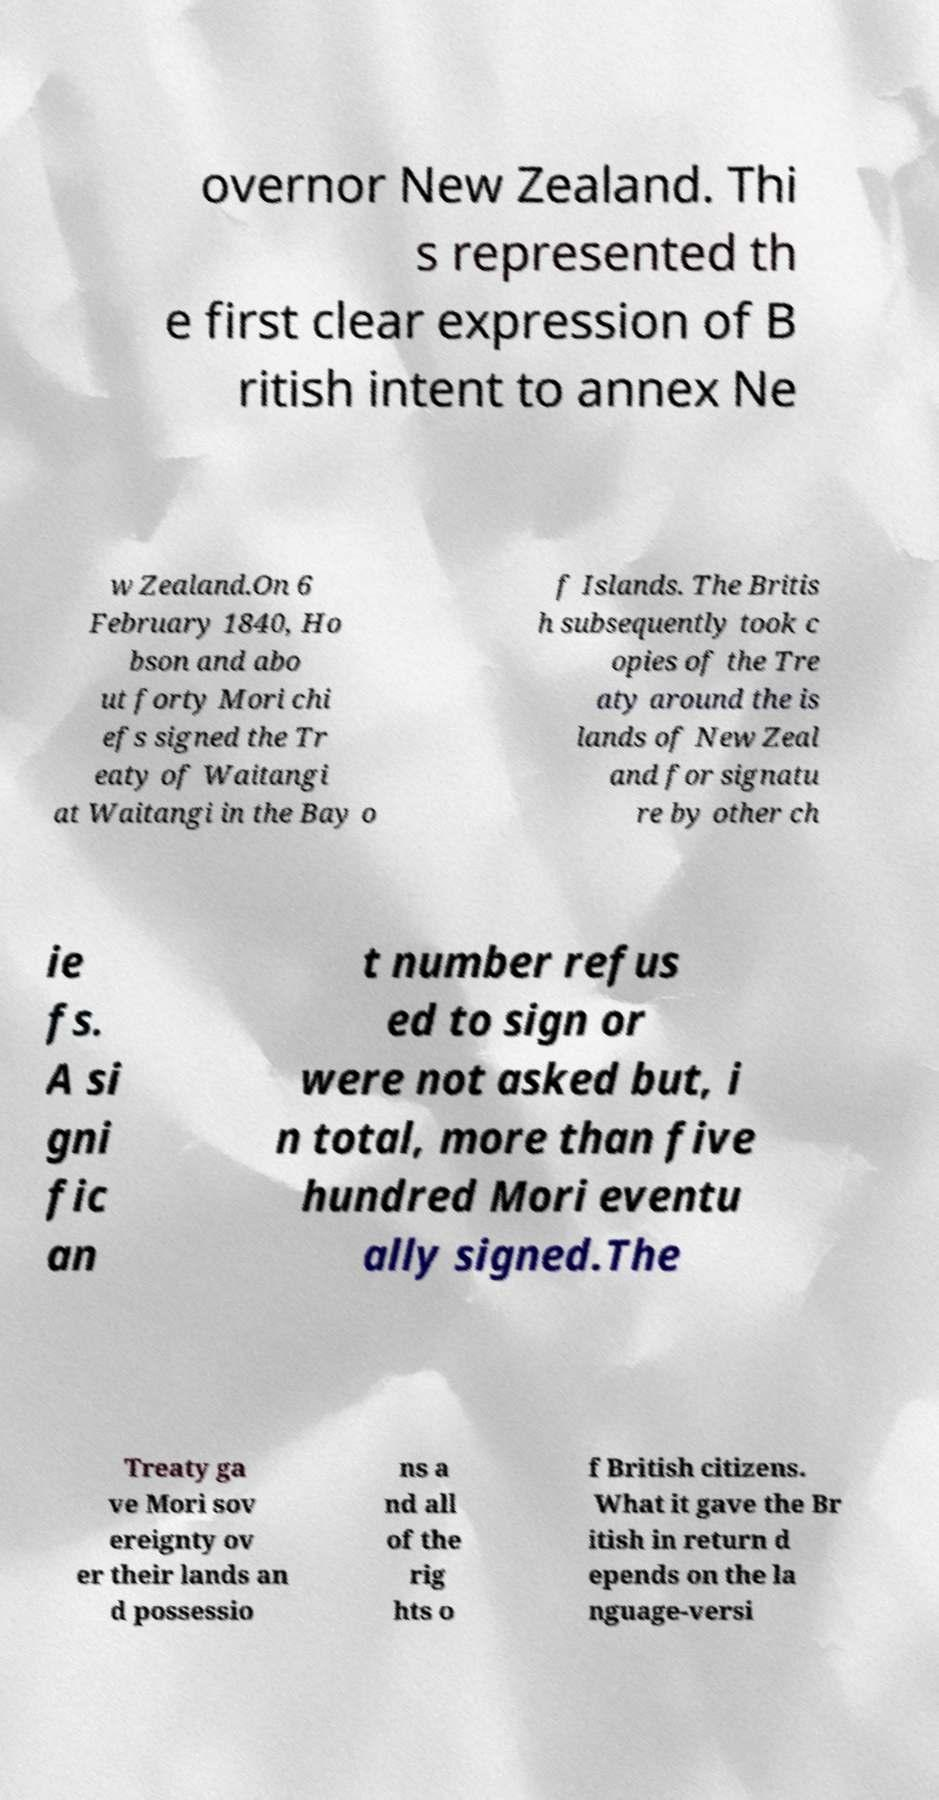For documentation purposes, I need the text within this image transcribed. Could you provide that? overnor New Zealand. Thi s represented th e first clear expression of B ritish intent to annex Ne w Zealand.On 6 February 1840, Ho bson and abo ut forty Mori chi efs signed the Tr eaty of Waitangi at Waitangi in the Bay o f Islands. The Britis h subsequently took c opies of the Tre aty around the is lands of New Zeal and for signatu re by other ch ie fs. A si gni fic an t number refus ed to sign or were not asked but, i n total, more than five hundred Mori eventu ally signed.The Treaty ga ve Mori sov ereignty ov er their lands an d possessio ns a nd all of the rig hts o f British citizens. What it gave the Br itish in return d epends on the la nguage-versi 